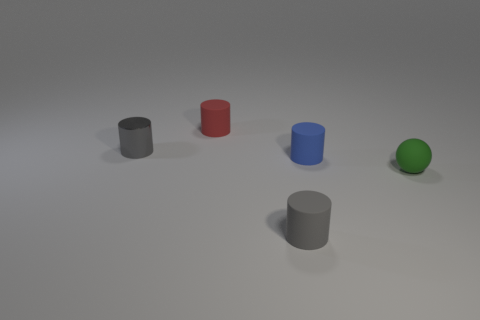Subtract all blue cylinders. How many cylinders are left? 3 Subtract all small blue cylinders. How many cylinders are left? 3 Subtract all green cylinders. Subtract all blue cubes. How many cylinders are left? 4 Add 1 tiny gray metallic things. How many objects exist? 6 Subtract all spheres. How many objects are left? 4 Subtract all small green spheres. Subtract all small blue cylinders. How many objects are left? 3 Add 4 small red rubber cylinders. How many small red rubber cylinders are left? 5 Add 1 small brown matte cylinders. How many small brown matte cylinders exist? 1 Subtract 0 red cubes. How many objects are left? 5 